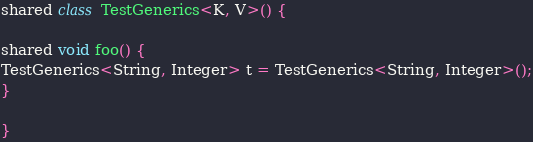Convert code to text. <code><loc_0><loc_0><loc_500><loc_500><_Ceylon_>shared class TestGenerics<K, V>() {

shared void foo() {
TestGenerics<String, Integer> t = TestGenerics<String, Integer>();
}

}
</code> 